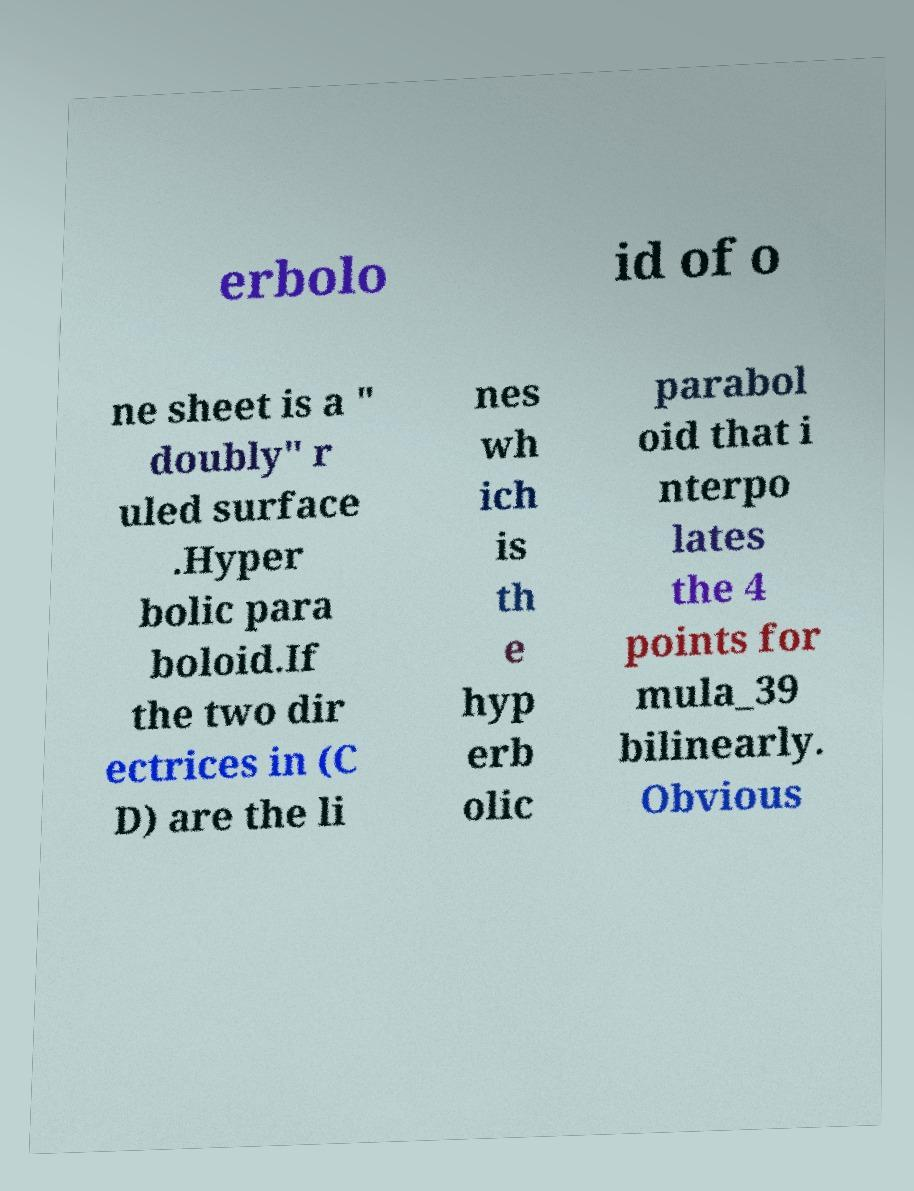Please identify and transcribe the text found in this image. erbolo id of o ne sheet is a " doubly" r uled surface .Hyper bolic para boloid.If the two dir ectrices in (C D) are the li nes wh ich is th e hyp erb olic parabol oid that i nterpo lates the 4 points for mula_39 bilinearly. Obvious 